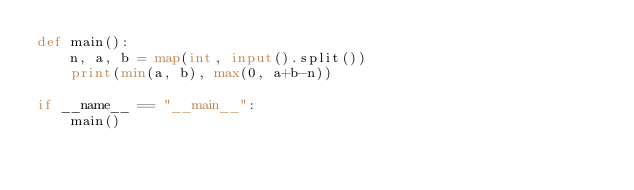<code> <loc_0><loc_0><loc_500><loc_500><_Python_>def main():
    n, a, b = map(int, input().split())
    print(min(a, b), max(0, a+b-n))

if __name__ == "__main__":
    main()</code> 